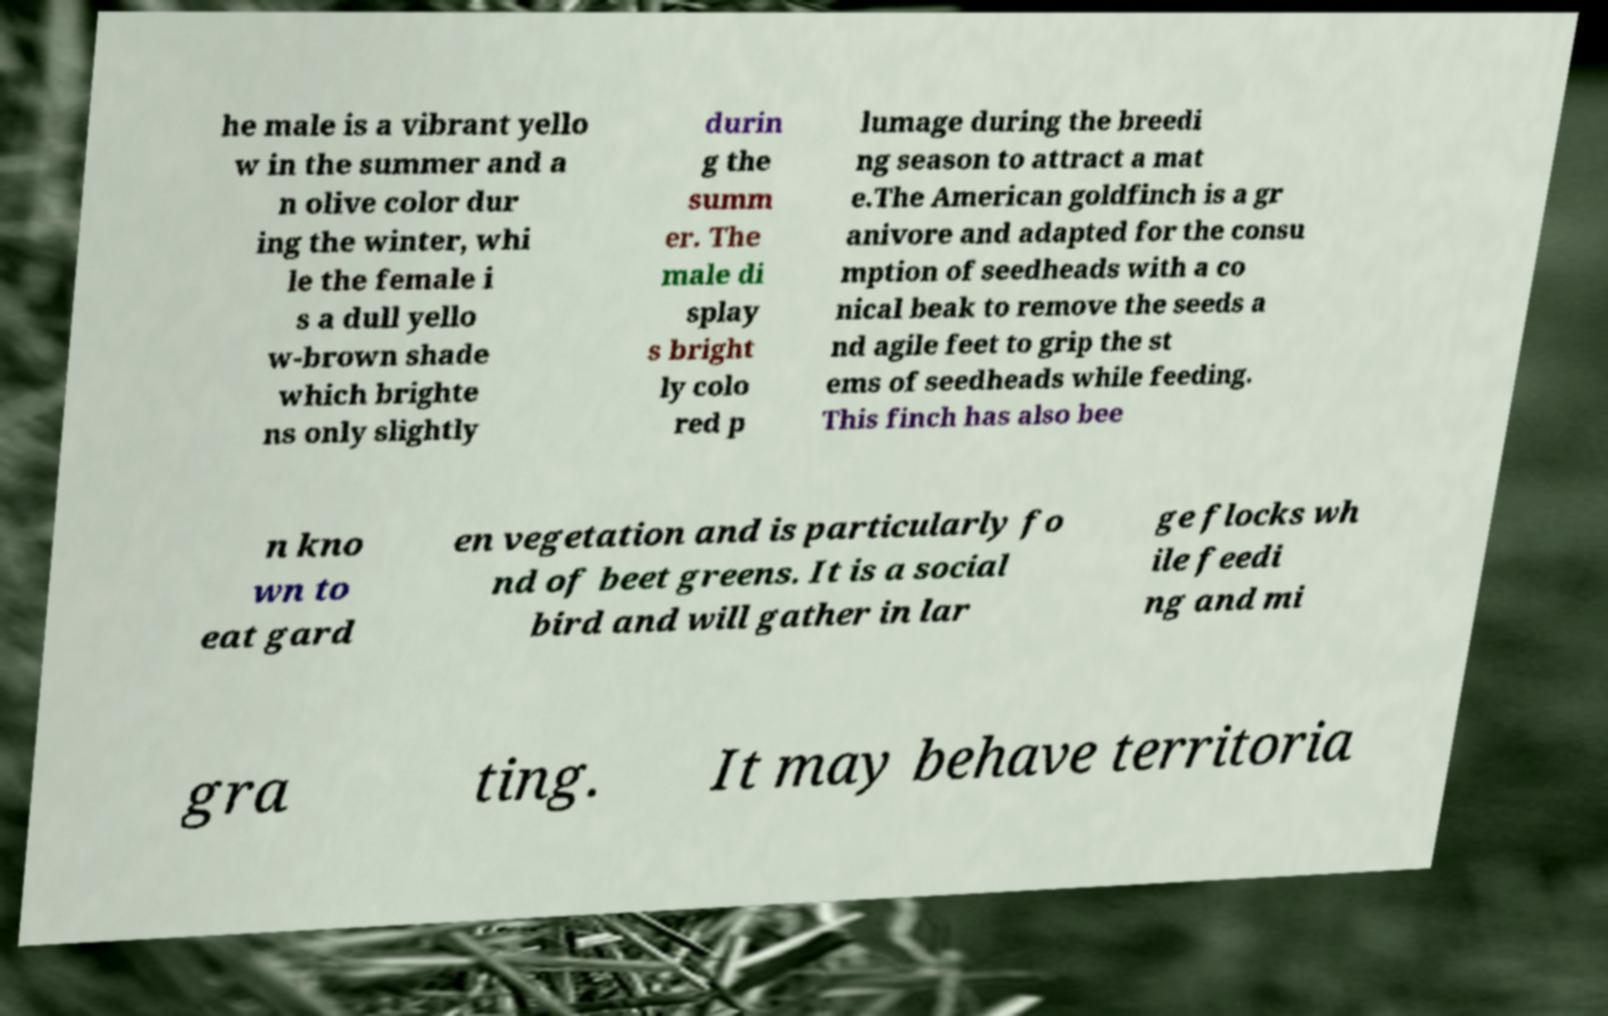I need the written content from this picture converted into text. Can you do that? he male is a vibrant yello w in the summer and a n olive color dur ing the winter, whi le the female i s a dull yello w-brown shade which brighte ns only slightly durin g the summ er. The male di splay s bright ly colo red p lumage during the breedi ng season to attract a mat e.The American goldfinch is a gr anivore and adapted for the consu mption of seedheads with a co nical beak to remove the seeds a nd agile feet to grip the st ems of seedheads while feeding. This finch has also bee n kno wn to eat gard en vegetation and is particularly fo nd of beet greens. It is a social bird and will gather in lar ge flocks wh ile feedi ng and mi gra ting. It may behave territoria 